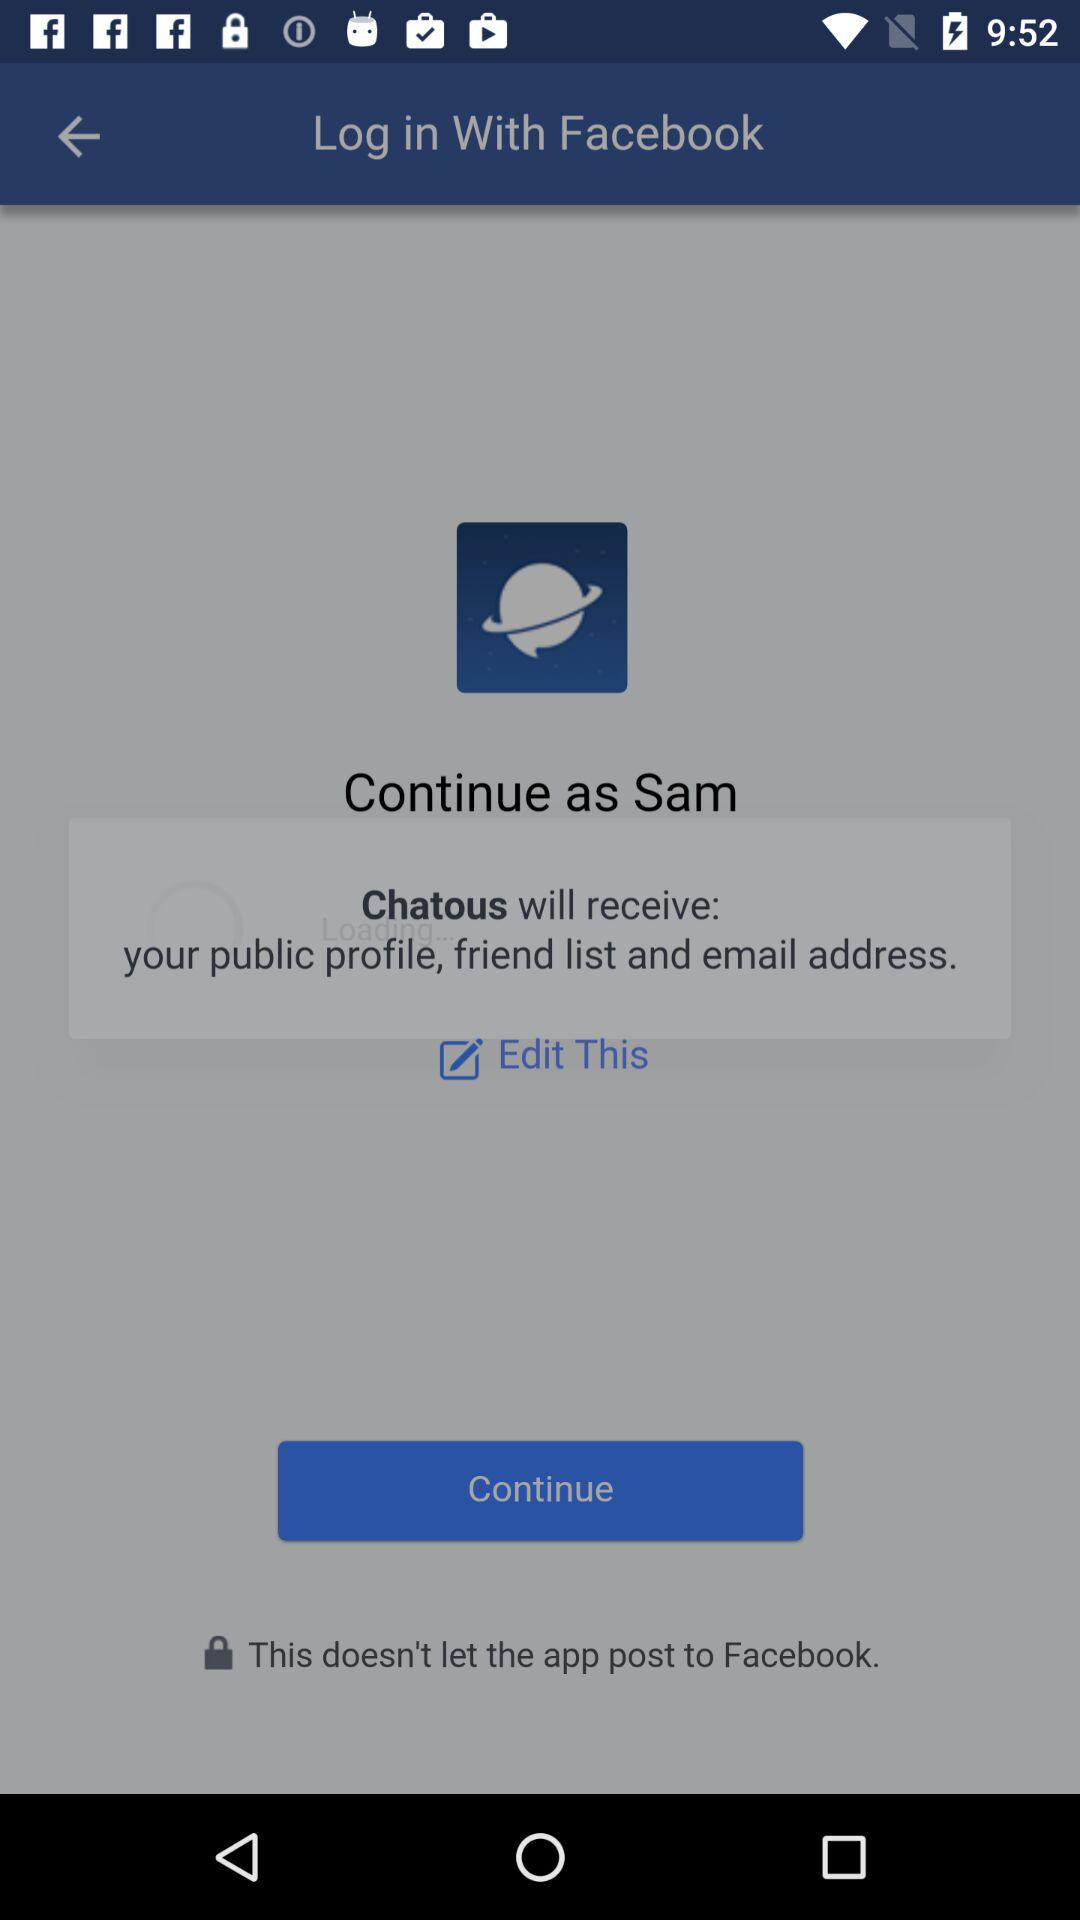What is the login name? The login name is Sam. 